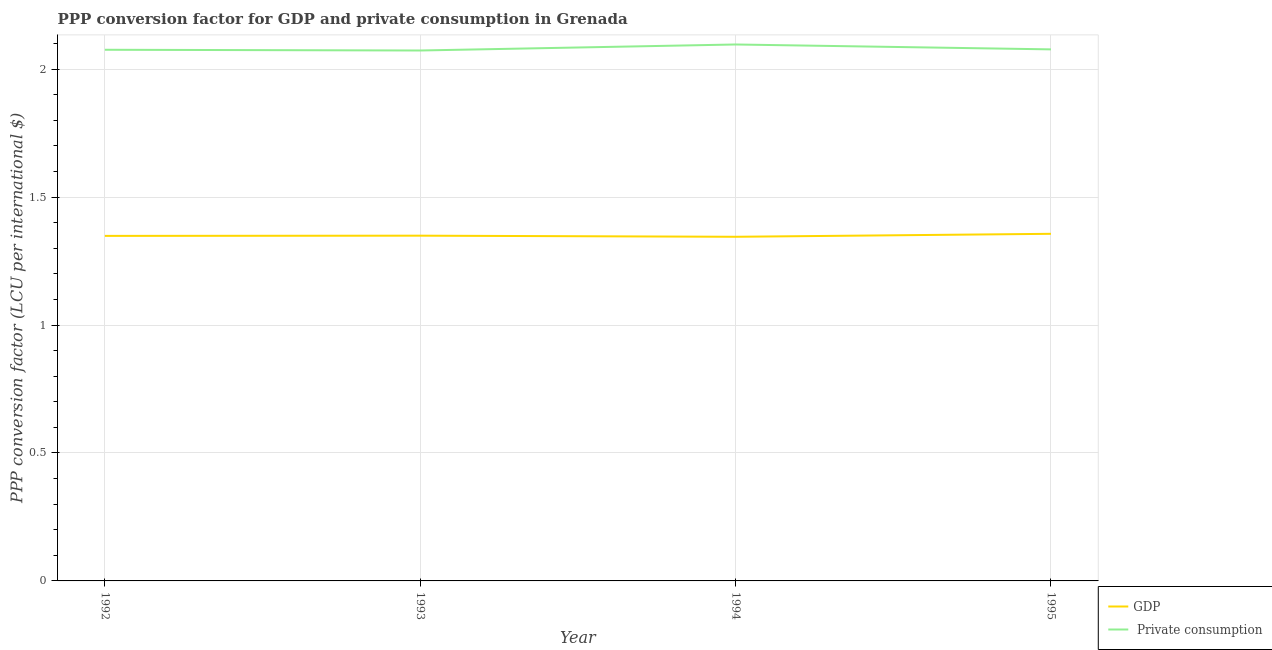How many different coloured lines are there?
Offer a terse response. 2. Does the line corresponding to ppp conversion factor for private consumption intersect with the line corresponding to ppp conversion factor for gdp?
Provide a short and direct response. No. Is the number of lines equal to the number of legend labels?
Ensure brevity in your answer.  Yes. What is the ppp conversion factor for gdp in 1995?
Your answer should be very brief. 1.36. Across all years, what is the maximum ppp conversion factor for gdp?
Ensure brevity in your answer.  1.36. Across all years, what is the minimum ppp conversion factor for gdp?
Provide a short and direct response. 1.35. In which year was the ppp conversion factor for gdp maximum?
Keep it short and to the point. 1995. In which year was the ppp conversion factor for private consumption minimum?
Provide a short and direct response. 1993. What is the total ppp conversion factor for private consumption in the graph?
Give a very brief answer. 8.32. What is the difference between the ppp conversion factor for gdp in 1992 and that in 1993?
Give a very brief answer. -0. What is the difference between the ppp conversion factor for private consumption in 1993 and the ppp conversion factor for gdp in 1994?
Offer a terse response. 0.73. What is the average ppp conversion factor for gdp per year?
Offer a terse response. 1.35. In the year 1994, what is the difference between the ppp conversion factor for gdp and ppp conversion factor for private consumption?
Provide a short and direct response. -0.75. In how many years, is the ppp conversion factor for gdp greater than 1.3 LCU?
Give a very brief answer. 4. What is the ratio of the ppp conversion factor for gdp in 1992 to that in 1995?
Your answer should be compact. 0.99. Is the difference between the ppp conversion factor for gdp in 1992 and 1995 greater than the difference between the ppp conversion factor for private consumption in 1992 and 1995?
Make the answer very short. No. What is the difference between the highest and the second highest ppp conversion factor for private consumption?
Provide a short and direct response. 0.02. What is the difference between the highest and the lowest ppp conversion factor for private consumption?
Keep it short and to the point. 0.02. In how many years, is the ppp conversion factor for private consumption greater than the average ppp conversion factor for private consumption taken over all years?
Give a very brief answer. 1. Is the sum of the ppp conversion factor for gdp in 1992 and 1994 greater than the maximum ppp conversion factor for private consumption across all years?
Keep it short and to the point. Yes. How many years are there in the graph?
Give a very brief answer. 4. Are the values on the major ticks of Y-axis written in scientific E-notation?
Your response must be concise. No. Does the graph contain any zero values?
Offer a terse response. No. Where does the legend appear in the graph?
Offer a terse response. Bottom right. How are the legend labels stacked?
Make the answer very short. Vertical. What is the title of the graph?
Make the answer very short. PPP conversion factor for GDP and private consumption in Grenada. Does "Residents" appear as one of the legend labels in the graph?
Your answer should be compact. No. What is the label or title of the Y-axis?
Give a very brief answer. PPP conversion factor (LCU per international $). What is the PPP conversion factor (LCU per international $) of GDP in 1992?
Offer a very short reply. 1.35. What is the PPP conversion factor (LCU per international $) of  Private consumption in 1992?
Give a very brief answer. 2.08. What is the PPP conversion factor (LCU per international $) in GDP in 1993?
Your response must be concise. 1.35. What is the PPP conversion factor (LCU per international $) of  Private consumption in 1993?
Offer a very short reply. 2.07. What is the PPP conversion factor (LCU per international $) in GDP in 1994?
Provide a succinct answer. 1.35. What is the PPP conversion factor (LCU per international $) of  Private consumption in 1994?
Give a very brief answer. 2.1. What is the PPP conversion factor (LCU per international $) in GDP in 1995?
Your answer should be compact. 1.36. What is the PPP conversion factor (LCU per international $) in  Private consumption in 1995?
Your answer should be compact. 2.08. Across all years, what is the maximum PPP conversion factor (LCU per international $) in GDP?
Offer a terse response. 1.36. Across all years, what is the maximum PPP conversion factor (LCU per international $) of  Private consumption?
Your response must be concise. 2.1. Across all years, what is the minimum PPP conversion factor (LCU per international $) in GDP?
Give a very brief answer. 1.35. Across all years, what is the minimum PPP conversion factor (LCU per international $) in  Private consumption?
Your answer should be very brief. 2.07. What is the total PPP conversion factor (LCU per international $) of GDP in the graph?
Make the answer very short. 5.4. What is the total PPP conversion factor (LCU per international $) of  Private consumption in the graph?
Offer a terse response. 8.32. What is the difference between the PPP conversion factor (LCU per international $) of GDP in 1992 and that in 1993?
Offer a very short reply. -0. What is the difference between the PPP conversion factor (LCU per international $) in  Private consumption in 1992 and that in 1993?
Provide a short and direct response. 0. What is the difference between the PPP conversion factor (LCU per international $) of GDP in 1992 and that in 1994?
Provide a succinct answer. 0. What is the difference between the PPP conversion factor (LCU per international $) of  Private consumption in 1992 and that in 1994?
Your answer should be very brief. -0.02. What is the difference between the PPP conversion factor (LCU per international $) in GDP in 1992 and that in 1995?
Keep it short and to the point. -0.01. What is the difference between the PPP conversion factor (LCU per international $) of  Private consumption in 1992 and that in 1995?
Your answer should be compact. -0. What is the difference between the PPP conversion factor (LCU per international $) in GDP in 1993 and that in 1994?
Your answer should be very brief. 0. What is the difference between the PPP conversion factor (LCU per international $) in  Private consumption in 1993 and that in 1994?
Ensure brevity in your answer.  -0.02. What is the difference between the PPP conversion factor (LCU per international $) of GDP in 1993 and that in 1995?
Offer a very short reply. -0.01. What is the difference between the PPP conversion factor (LCU per international $) of  Private consumption in 1993 and that in 1995?
Make the answer very short. -0. What is the difference between the PPP conversion factor (LCU per international $) of GDP in 1994 and that in 1995?
Offer a terse response. -0.01. What is the difference between the PPP conversion factor (LCU per international $) in  Private consumption in 1994 and that in 1995?
Your answer should be very brief. 0.02. What is the difference between the PPP conversion factor (LCU per international $) of GDP in 1992 and the PPP conversion factor (LCU per international $) of  Private consumption in 1993?
Provide a short and direct response. -0.72. What is the difference between the PPP conversion factor (LCU per international $) in GDP in 1992 and the PPP conversion factor (LCU per international $) in  Private consumption in 1994?
Offer a terse response. -0.75. What is the difference between the PPP conversion factor (LCU per international $) in GDP in 1992 and the PPP conversion factor (LCU per international $) in  Private consumption in 1995?
Provide a succinct answer. -0.73. What is the difference between the PPP conversion factor (LCU per international $) in GDP in 1993 and the PPP conversion factor (LCU per international $) in  Private consumption in 1994?
Provide a short and direct response. -0.75. What is the difference between the PPP conversion factor (LCU per international $) in GDP in 1993 and the PPP conversion factor (LCU per international $) in  Private consumption in 1995?
Keep it short and to the point. -0.73. What is the difference between the PPP conversion factor (LCU per international $) in GDP in 1994 and the PPP conversion factor (LCU per international $) in  Private consumption in 1995?
Your answer should be very brief. -0.73. What is the average PPP conversion factor (LCU per international $) in GDP per year?
Your answer should be very brief. 1.35. What is the average PPP conversion factor (LCU per international $) in  Private consumption per year?
Your answer should be very brief. 2.08. In the year 1992, what is the difference between the PPP conversion factor (LCU per international $) of GDP and PPP conversion factor (LCU per international $) of  Private consumption?
Your answer should be compact. -0.73. In the year 1993, what is the difference between the PPP conversion factor (LCU per international $) of GDP and PPP conversion factor (LCU per international $) of  Private consumption?
Offer a very short reply. -0.72. In the year 1994, what is the difference between the PPP conversion factor (LCU per international $) of GDP and PPP conversion factor (LCU per international $) of  Private consumption?
Ensure brevity in your answer.  -0.75. In the year 1995, what is the difference between the PPP conversion factor (LCU per international $) in GDP and PPP conversion factor (LCU per international $) in  Private consumption?
Give a very brief answer. -0.72. What is the ratio of the PPP conversion factor (LCU per international $) in GDP in 1992 to that in 1993?
Provide a short and direct response. 1. What is the ratio of the PPP conversion factor (LCU per international $) of  Private consumption in 1992 to that in 1993?
Your response must be concise. 1. What is the ratio of the PPP conversion factor (LCU per international $) of  Private consumption in 1992 to that in 1994?
Make the answer very short. 0.99. What is the ratio of the PPP conversion factor (LCU per international $) in GDP in 1993 to that in 1995?
Your response must be concise. 0.99. What is the ratio of the PPP conversion factor (LCU per international $) in  Private consumption in 1993 to that in 1995?
Make the answer very short. 1. What is the ratio of the PPP conversion factor (LCU per international $) in  Private consumption in 1994 to that in 1995?
Your answer should be very brief. 1.01. What is the difference between the highest and the second highest PPP conversion factor (LCU per international $) of GDP?
Offer a very short reply. 0.01. What is the difference between the highest and the second highest PPP conversion factor (LCU per international $) in  Private consumption?
Your response must be concise. 0.02. What is the difference between the highest and the lowest PPP conversion factor (LCU per international $) of GDP?
Provide a short and direct response. 0.01. What is the difference between the highest and the lowest PPP conversion factor (LCU per international $) in  Private consumption?
Ensure brevity in your answer.  0.02. 